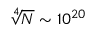<formula> <loc_0><loc_0><loc_500><loc_500>\sqrt { [ } 4 ] { N } \sim 1 0 ^ { 2 0 }</formula> 